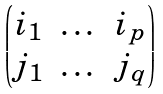<formula> <loc_0><loc_0><loc_500><loc_500>\begin{pmatrix} i _ { 1 } & \dots & i _ { p } \\ j _ { 1 } & \dots & j _ { q } \end{pmatrix}</formula> 